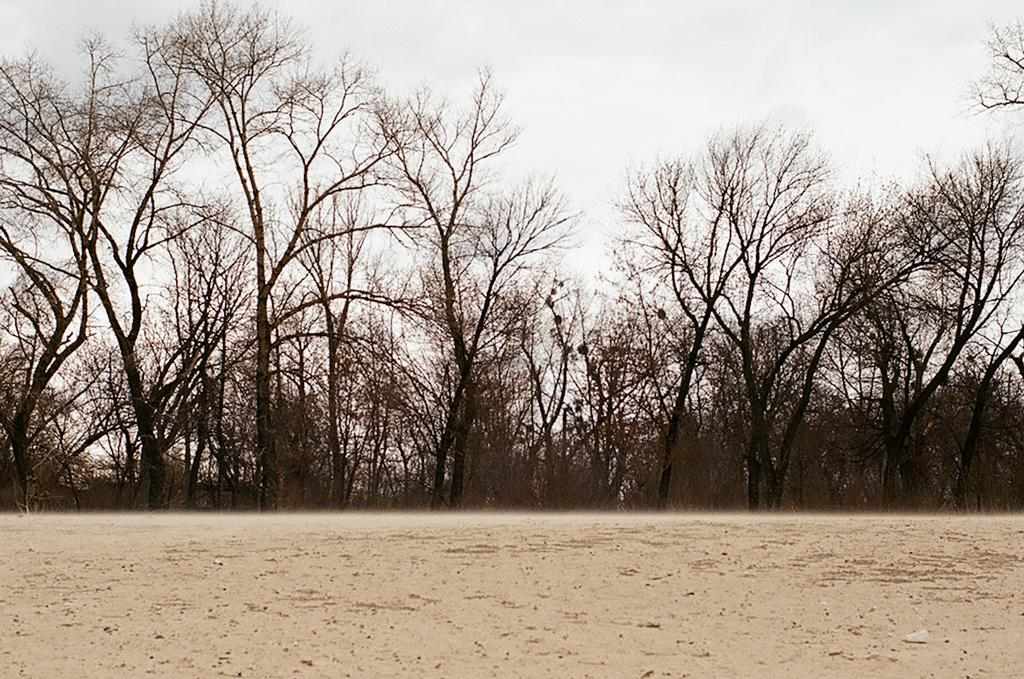What type of vegetation is present in the image? There are dry trees in the image. What type of terrain is visible in the image? There is sand visible in the image. What is the color of the sky in the image? The sky appears to be white in color. What type of health advice can be found in the image? There is no health advice present in the image; it features dry trees, sand, and a white sky. Is there a box visible in the image? There is no box present in the image. 